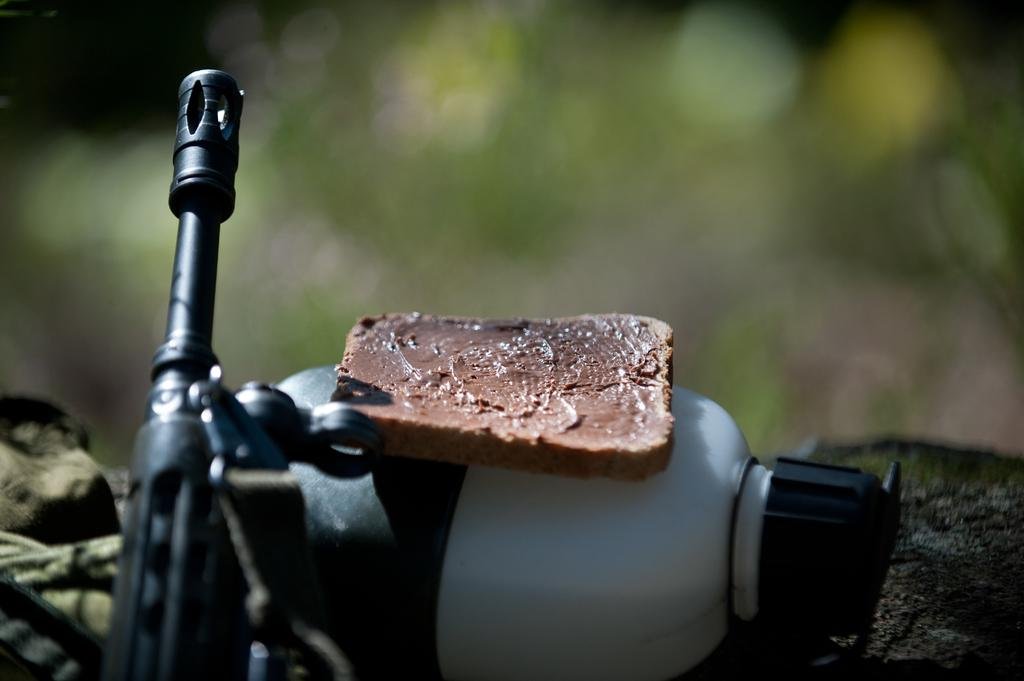What is placed on the bottle in the image? There is bread on a bottle in the image. What else can be seen in the image besides the bread on the bottle? There are other objects in the image. Can you describe the background of the image? The background of the image is blurry. What type of cough medicine is visible in the image? There is no cough medicine present in the image. Can you see any animals from the zoo in the image? There are no animals from the zoo present in the image. 